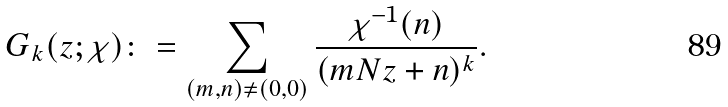<formula> <loc_0><loc_0><loc_500><loc_500>G _ { k } ( z ; \chi ) \colon = \sum _ { ( m , n ) \neq ( 0 , 0 ) } \frac { \chi ^ { - 1 } ( n ) } { ( m N z + n ) ^ { k } } .</formula> 